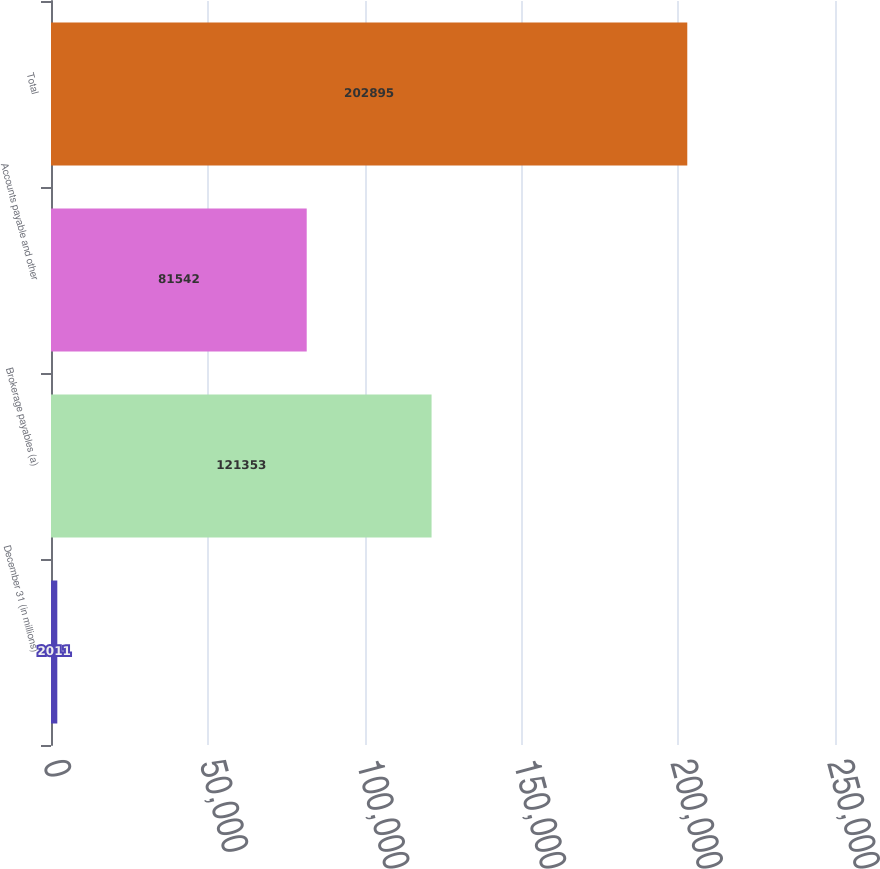Convert chart to OTSL. <chart><loc_0><loc_0><loc_500><loc_500><bar_chart><fcel>December 31 (in millions)<fcel>Brokerage payables (a)<fcel>Accounts payable and other<fcel>Total<nl><fcel>2011<fcel>121353<fcel>81542<fcel>202895<nl></chart> 